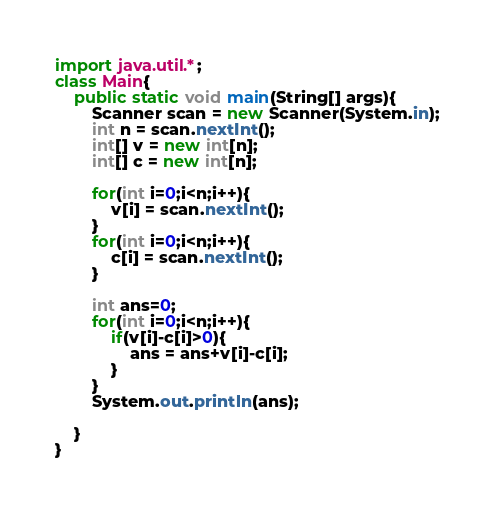<code> <loc_0><loc_0><loc_500><loc_500><_Java_>import java.util.*;
class Main{
	public static void main(String[] args){
    	Scanner scan = new Scanner(System.in);
      	int n = scan.nextInt();
        int[] v = new int[n];
        int[] c = new int[n];
      
      	for(int i=0;i<n;i++){
        	v[i] = scan.nextInt();
        }
      	for(int i=0;i<n;i++){
        	c[i] = scan.nextInt();
        }
      	
      	int ans=0;
      	for(int i=0;i<n;i++){
        	if(v[i]-c[i]>0){
            	ans = ans+v[i]-c[i];
            }
        }
      	System.out.println(ans);
      
    }
}</code> 